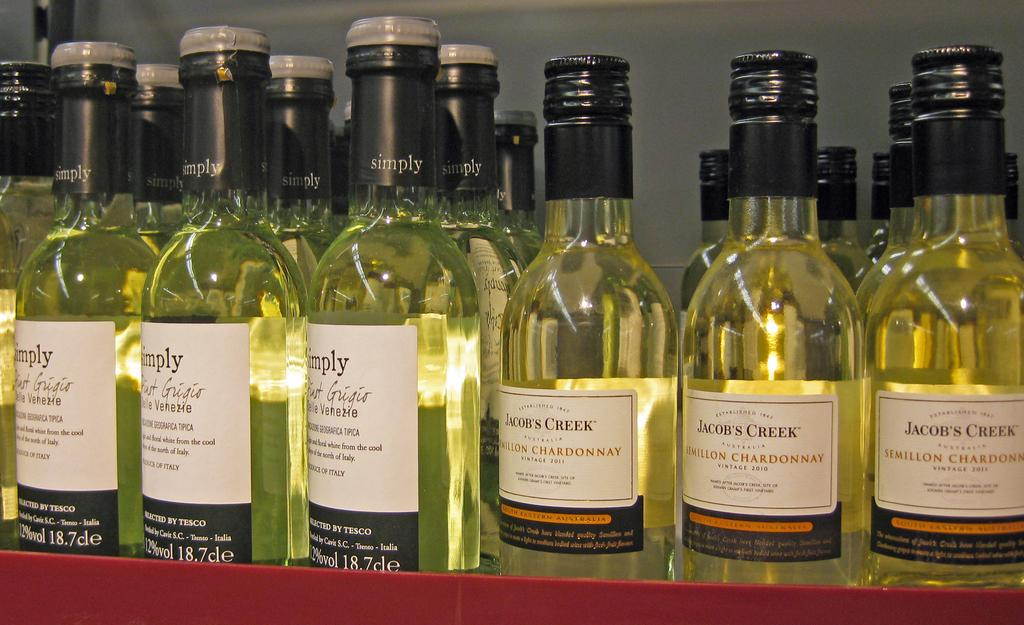<image>
Create a compact narrative representing the image presented. Jacobs creek chardonnay wine in twist off cap 